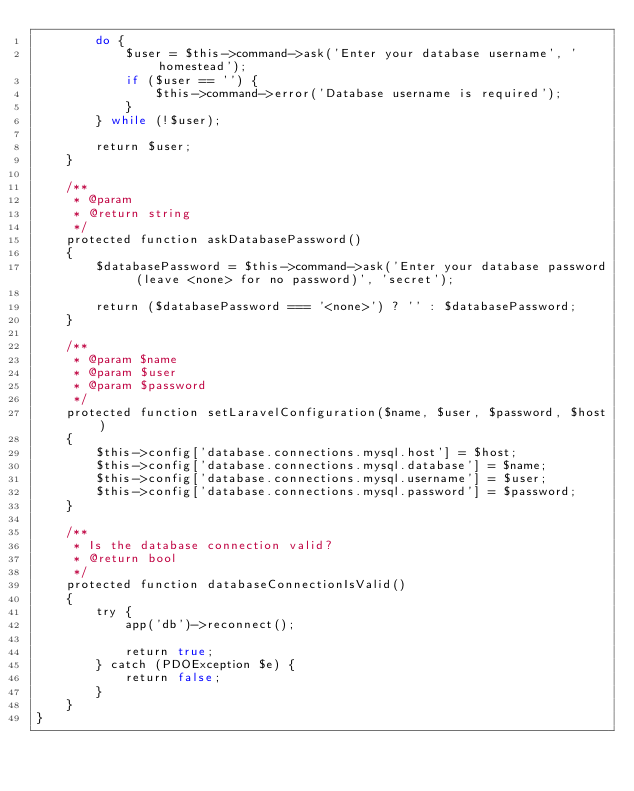Convert code to text. <code><loc_0><loc_0><loc_500><loc_500><_PHP_>        do {
            $user = $this->command->ask('Enter your database username', 'homestead');
            if ($user == '') {
                $this->command->error('Database username is required');
            }
        } while (!$user);

        return $user;
    }

    /**
     * @param
     * @return string
     */
    protected function askDatabasePassword()
    {
        $databasePassword = $this->command->ask('Enter your database password (leave <none> for no password)', 'secret');

        return ($databasePassword === '<none>') ? '' : $databasePassword;
    }

    /**
     * @param $name
     * @param $user
     * @param $password
     */
    protected function setLaravelConfiguration($name, $user, $password, $host)
    {
        $this->config['database.connections.mysql.host'] = $host;
        $this->config['database.connections.mysql.database'] = $name;
        $this->config['database.connections.mysql.username'] = $user;
        $this->config['database.connections.mysql.password'] = $password;
    }

    /**
     * Is the database connection valid?
     * @return bool
     */
    protected function databaseConnectionIsValid()
    {
        try {
            app('db')->reconnect();

            return true;
        } catch (PDOException $e) {
            return false;
        }
    }
}
</code> 